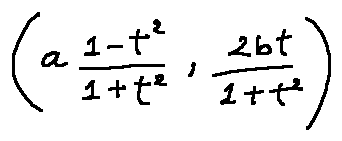<formula> <loc_0><loc_0><loc_500><loc_500>( a \frac { 1 - t ^ { 2 } } { 1 + t ^ { 2 } } , \frac { 2 b t } { 1 + t ^ { 2 } } )</formula> 